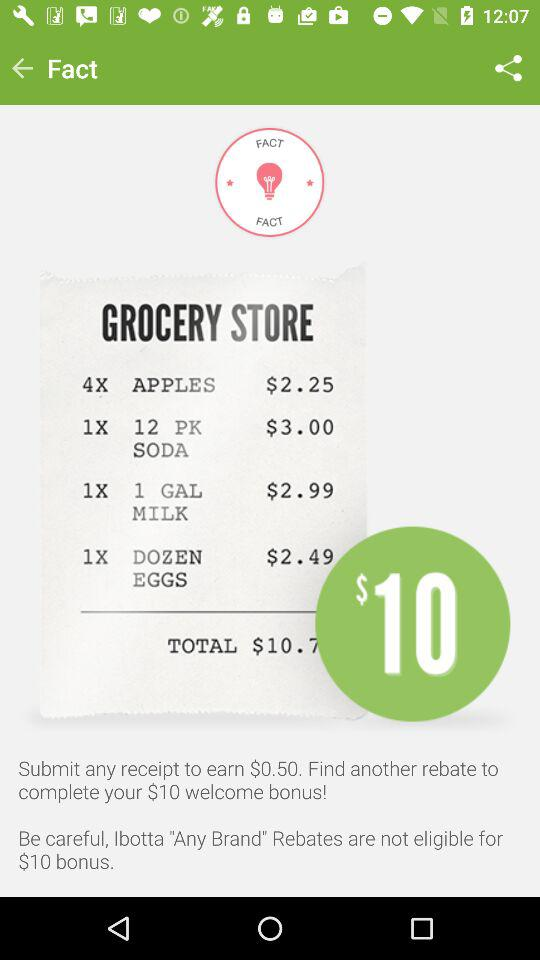What is the price of "1 DOZEN EGGS"? The price of "1 DOZEN EGGS" is $2.49. 